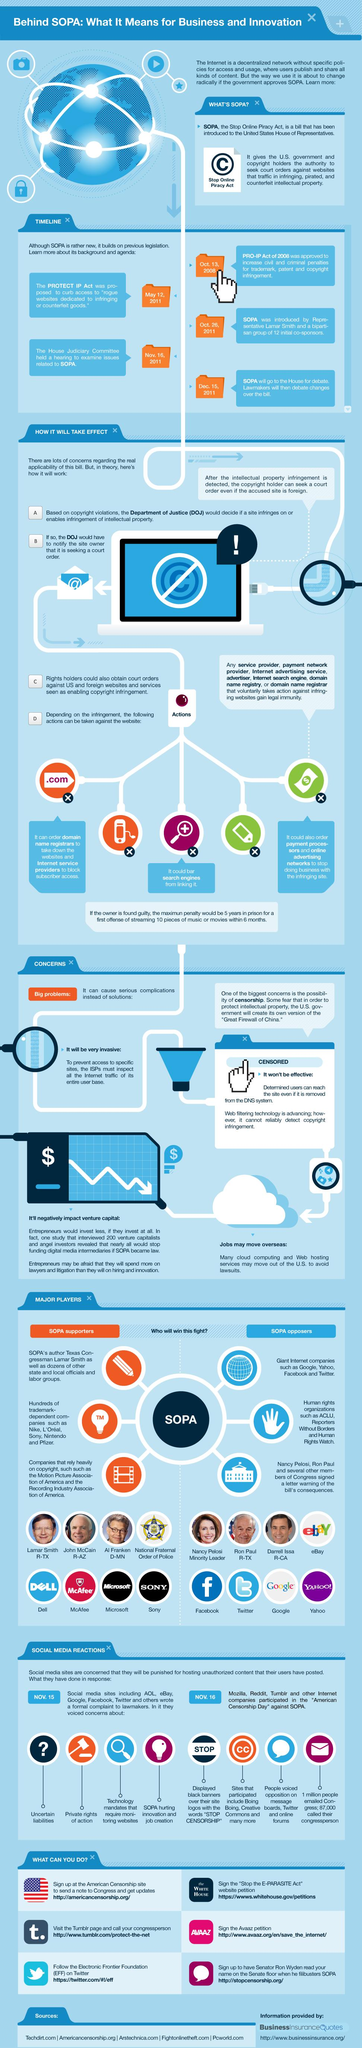Identify some key points in this picture. The Internet leaders Google, Yahoo, Facebook, and Twitter are against SOPA. Supporters of SOPA are represented by the color code of yellow, red, orange, and green. The color code for supporters of SOPA is orange. People who are against SOPA are assigned a color code of yellow, blue, orange, and green, with blue being the primary color. 